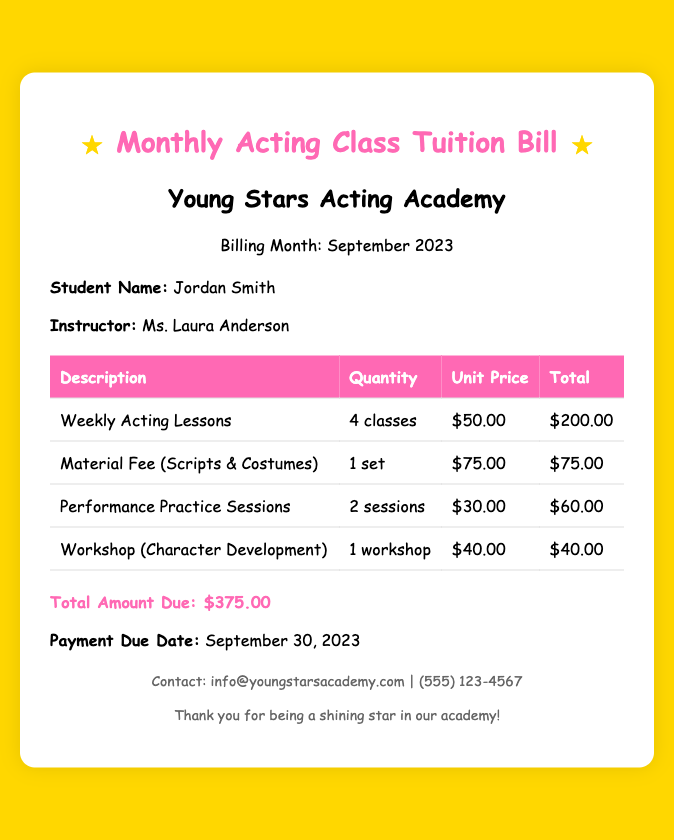What is the total amount due? The total amount due is the sum of all itemized fees, which is $375.00.
Answer: $375.00 What is the name of the student? The document lists the student's name as Jordan Smith.
Answer: Jordan Smith Who is the instructor? The instructor mentioned in the document is Ms. Laura Anderson.
Answer: Ms. Laura Anderson How many weekly acting lessons are included? The bill states there are 4 classes of weekly acting lessons provided.
Answer: 4 classes What is the material fee total? The material fee for scripts and costumes is listed as $75.00.
Answer: $75.00 When is the payment due date? The due date for the payment is September 30, 2023.
Answer: September 30, 2023 How many performance practice sessions were charged? The document indicates that there are 2 performance practice sessions included in the bill.
Answer: 2 sessions What workshop is included in the bill? The bill includes a workshop focused on character development.
Answer: Character Development What is the unit price for a performance practice session? The bill specifies the unit price for a performance practice session as $30.00.
Answer: $30.00 